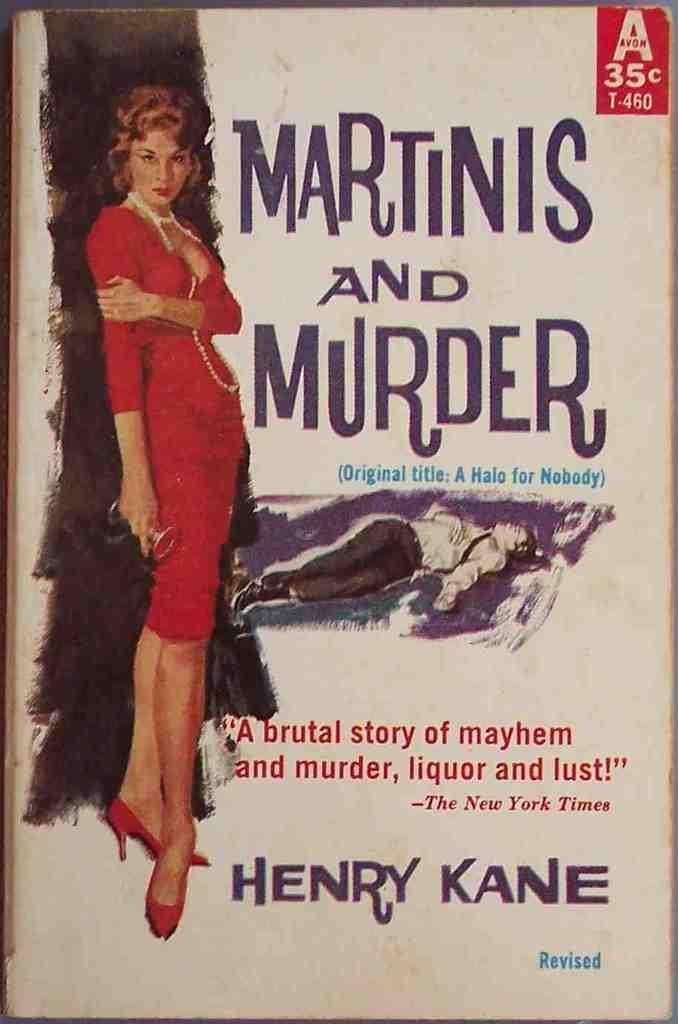What type of item is the image likely to be a part of? The image appears to be the cover page of a book. Can you describe the people depicted on the cover? There are depictions of two people on the cover. Are there any names associated with the people on the cover? Yes, there are names associated with the depictions of the people. What else can be seen on the cover page? There is some text on the cover page. Is there a house depicted on the cover page? No, there is no house depicted on the cover page. What type of reward is being offered to the people on the cover? There is no mention of a reward on the cover page. 